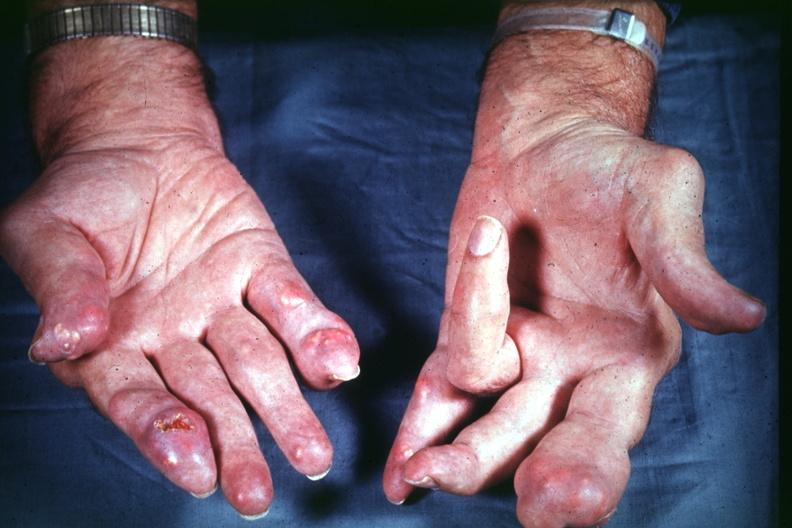does this image show good example source of gout?
Answer the question using a single word or phrase. Yes 